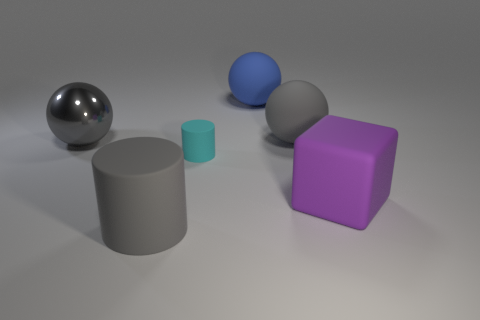Add 3 purple matte objects. How many objects exist? 9 Subtract all cylinders. How many objects are left? 4 Add 2 small brown rubber cylinders. How many small brown rubber cylinders exist? 2 Subtract 0 blue cylinders. How many objects are left? 6 Subtract all gray shiny things. Subtract all cyan rubber balls. How many objects are left? 5 Add 3 large blue matte things. How many large blue matte things are left? 4 